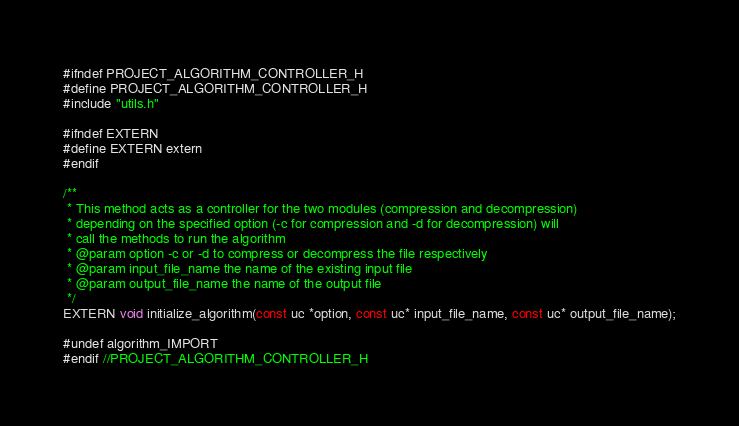<code> <loc_0><loc_0><loc_500><loc_500><_C_>#ifndef PROJECT_ALGORITHM_CONTROLLER_H
#define PROJECT_ALGORITHM_CONTROLLER_H
#include "utils.h"

#ifndef EXTERN
#define EXTERN extern
#endif

/**
 * This method acts as a controller for the two modules (compression and decompression)
 * depending on the specified option (-c for compression and -d for decompression) will
 * call the methods to run the algorithm
 * @param option -c or -d to compress or decompress the file respectively
 * @param input_file_name the name of the existing input file 
 * @param output_file_name the name of the output file
 */
EXTERN void initialize_algorithm(const uc *option, const uc* input_file_name, const uc* output_file_name);

#undef algorithm_IMPORT
#endif //PROJECT_ALGORITHM_CONTROLLER_H</code> 